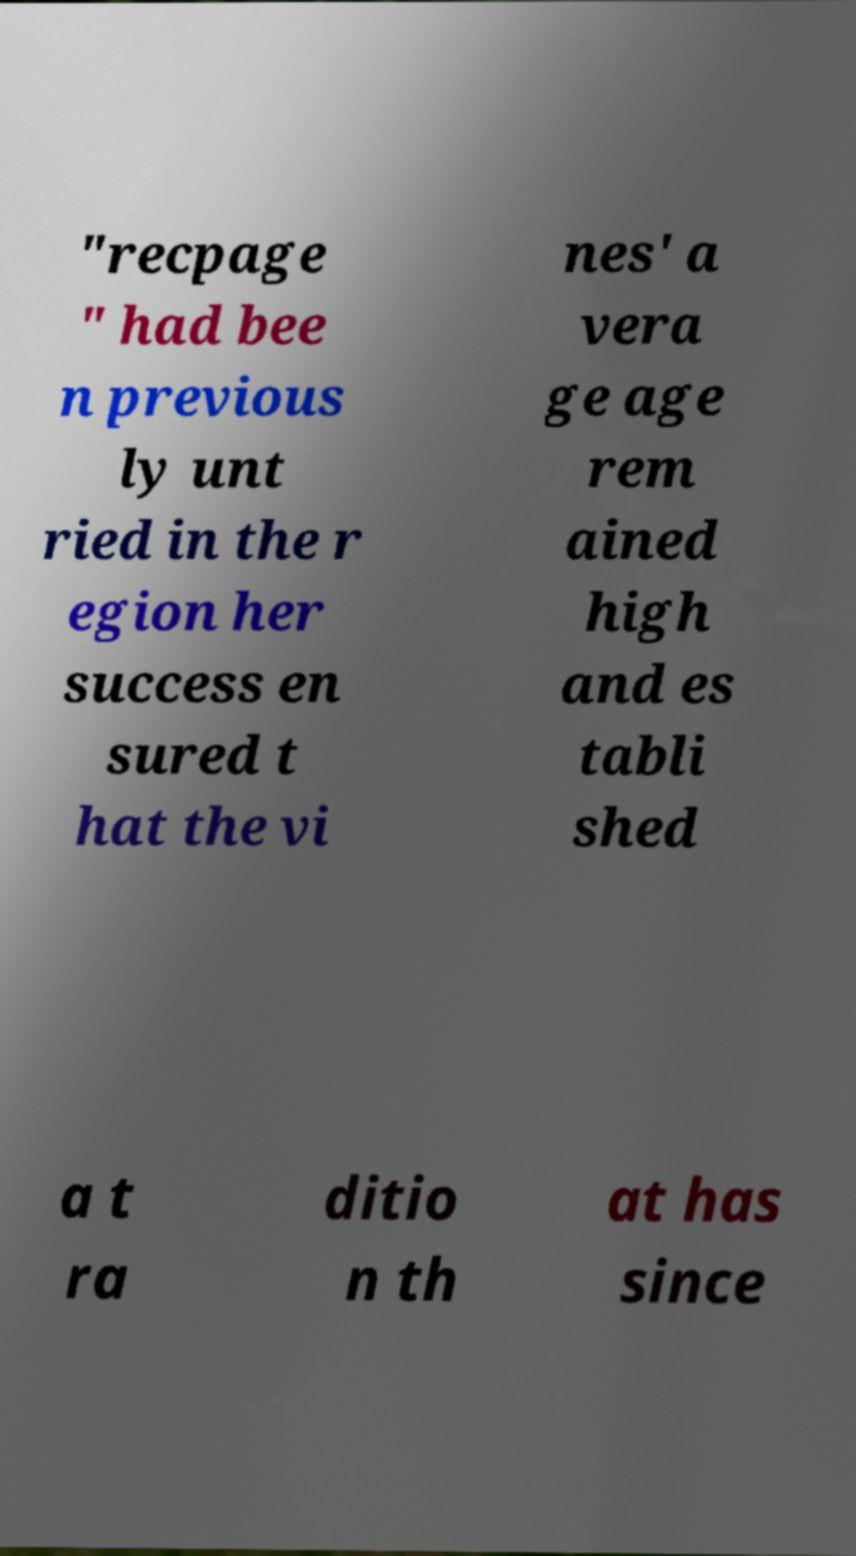What messages or text are displayed in this image? I need them in a readable, typed format. "recpage " had bee n previous ly unt ried in the r egion her success en sured t hat the vi nes' a vera ge age rem ained high and es tabli shed a t ra ditio n th at has since 